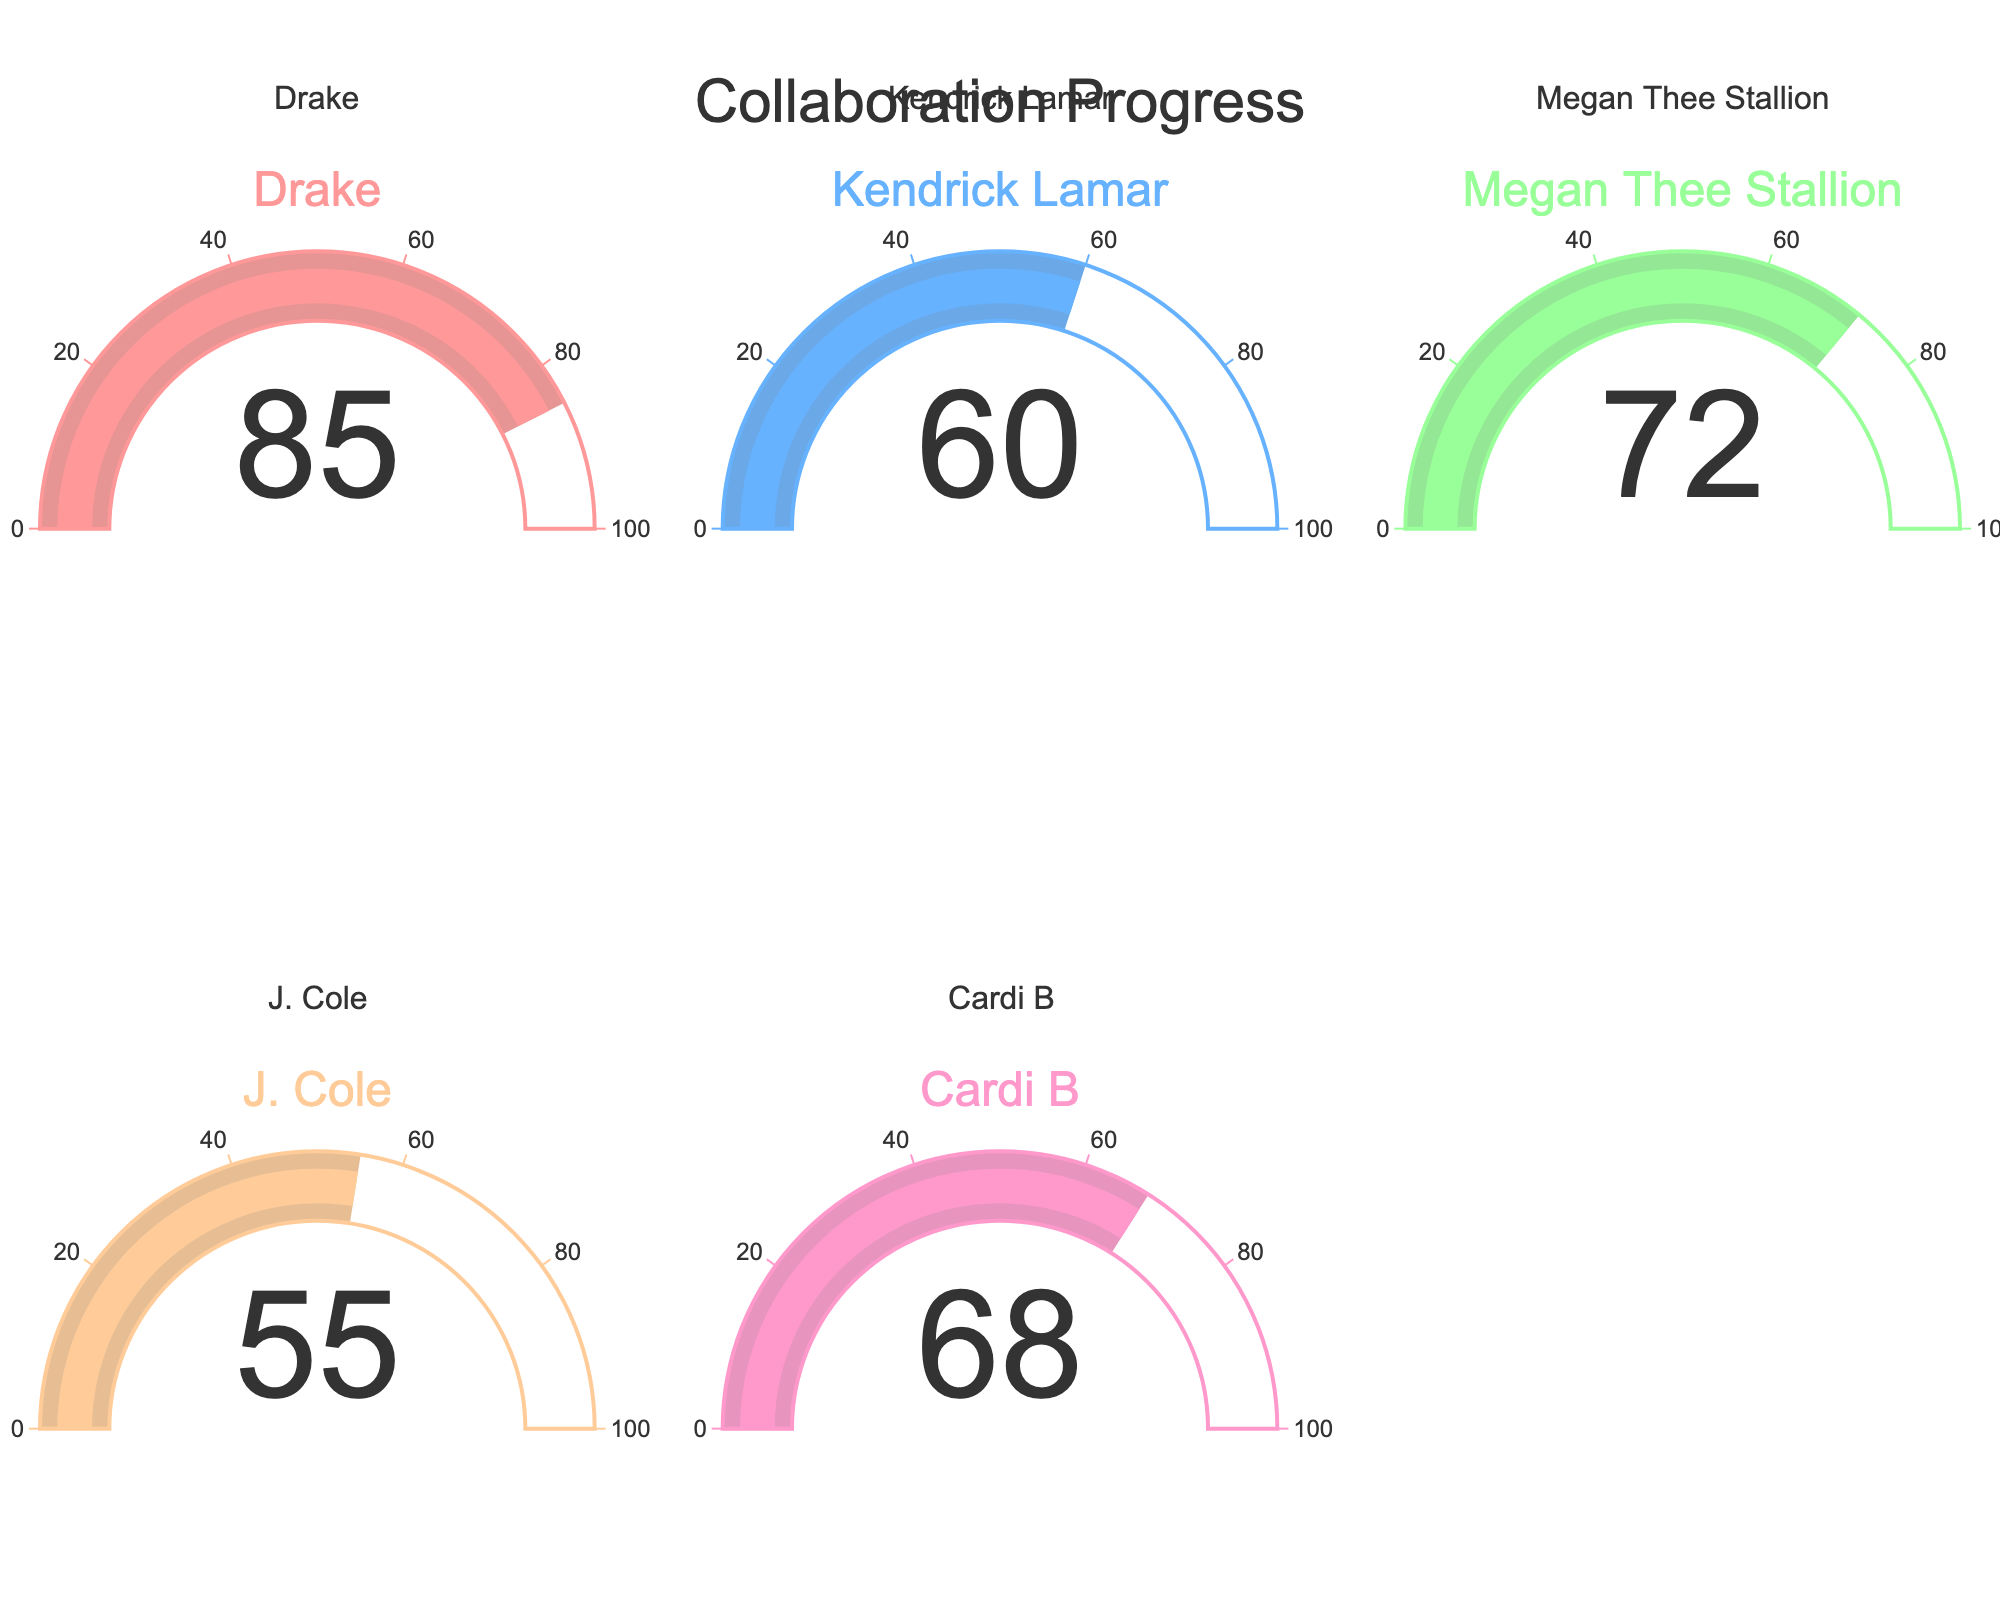what percentage is shown for Drake? The gauge for Drake shows an indicator reading the percentage of desired collaboration.
Answer: 85% which collaborator has the lowest percentage secured? By comparing the gauge indicators for all collaborators, we see that J. Cole has the lowest percentage.
Answer: J. Cole What’s the average percentage of all collaborators combined? To calculate the average, sum up all the percentages and divide by the number of collaborators: (85 + 60 + 72 + 55 + 68) / 5 = 68.
Answer: 68 Which collaborator has a higher percentage, Megan Thee Stallion or Cardi B? By looking at the gauges, Megan Thee Stallion has 72% and Cardi B has 68%. Comparing these, Megan Thee Stallion has a higher percentage.
Answer: Megan Thee Stallion What's the difference in percentage between J. Cole and Drake? Subtract J. Cole's percentage from Drake's: 85 - 55 = 30.
Answer: 30 How many collaborators have secured more than 60%? By checking each gauge, the collaborators with more than 60% are Drake, Megan Thee Stallion, and Cardi B.
Answer: 3 What is the combined percentage of Kendrick Lamar and Cardi B? Combine their percentages: 60 + 68 = 128.
Answer: 128 Which collaborator is closest to the average percentage? The average percentage is 68. The collaborator closest to this value is Cardi B, with 68%.
Answer: Cardi B What's the range of percentages shown across all collaborators? To find the range, subtract the lowest percentage from the highest percentage: 85 - 55 = 30.
Answer: 30 What is the median percentage of the percentages shown? Arrange the percentages (55, 60, 68, 72, 85). The middle value is the third one, which is 68.
Answer: 68 